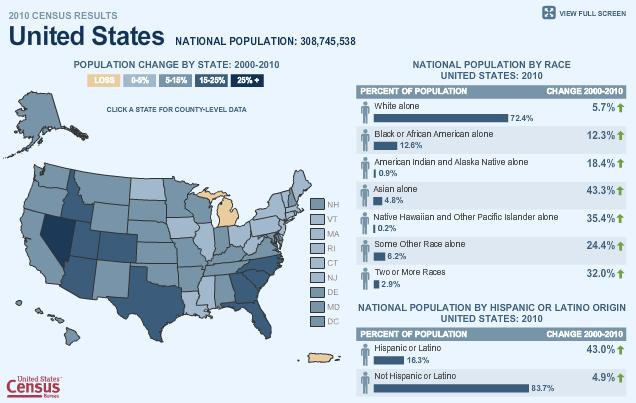Mention a couple of crucial points in this snapshot. The combined percentage of white and Asian individuals is 77.2%. According to the given information, 85% of the population is made up of white and black individuals who are being targeted. 